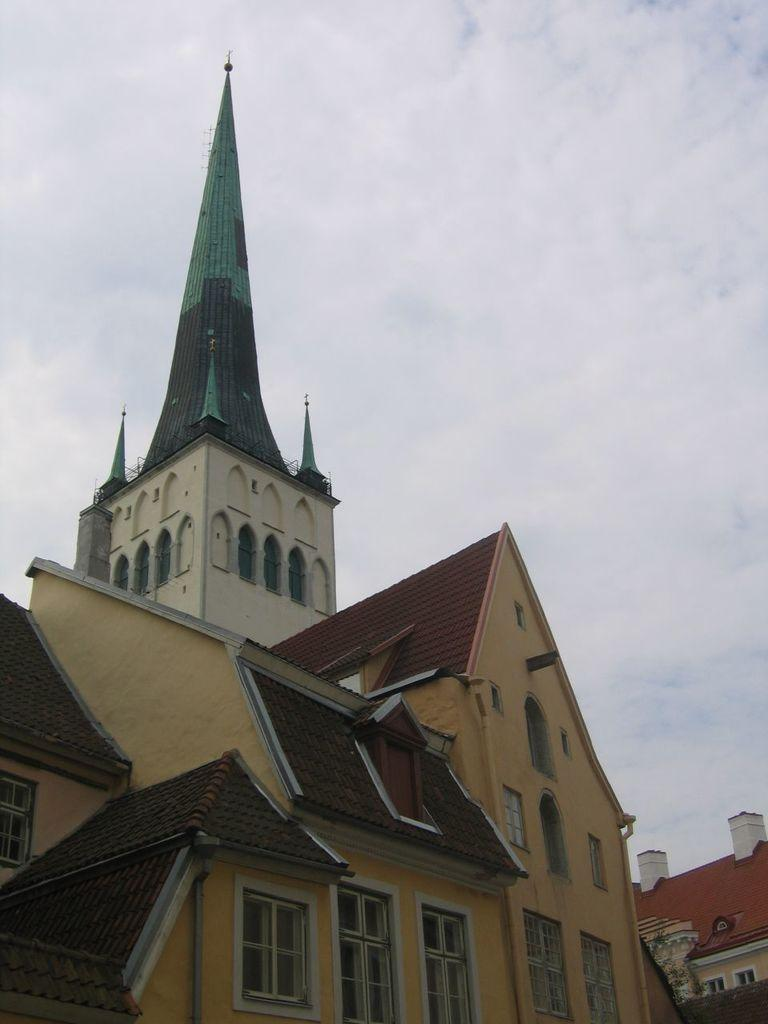What type of structures can be seen in the image? There are buildings in the image. What is visible at the top of the image? The sky is visible at the top of the image. How many giants can be seen walking along the line in the image? There are no giants or lines present in the image; it features buildings and the sky. 